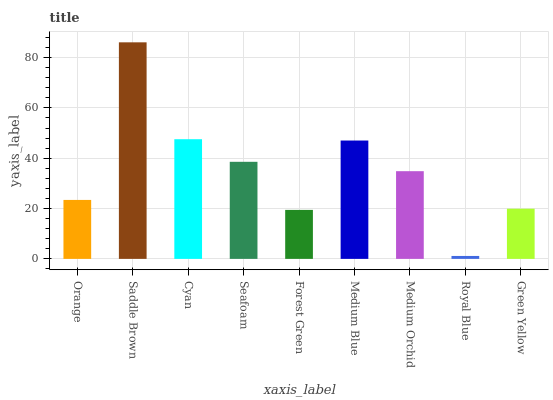Is Royal Blue the minimum?
Answer yes or no. Yes. Is Saddle Brown the maximum?
Answer yes or no. Yes. Is Cyan the minimum?
Answer yes or no. No. Is Cyan the maximum?
Answer yes or no. No. Is Saddle Brown greater than Cyan?
Answer yes or no. Yes. Is Cyan less than Saddle Brown?
Answer yes or no. Yes. Is Cyan greater than Saddle Brown?
Answer yes or no. No. Is Saddle Brown less than Cyan?
Answer yes or no. No. Is Medium Orchid the high median?
Answer yes or no. Yes. Is Medium Orchid the low median?
Answer yes or no. Yes. Is Green Yellow the high median?
Answer yes or no. No. Is Green Yellow the low median?
Answer yes or no. No. 